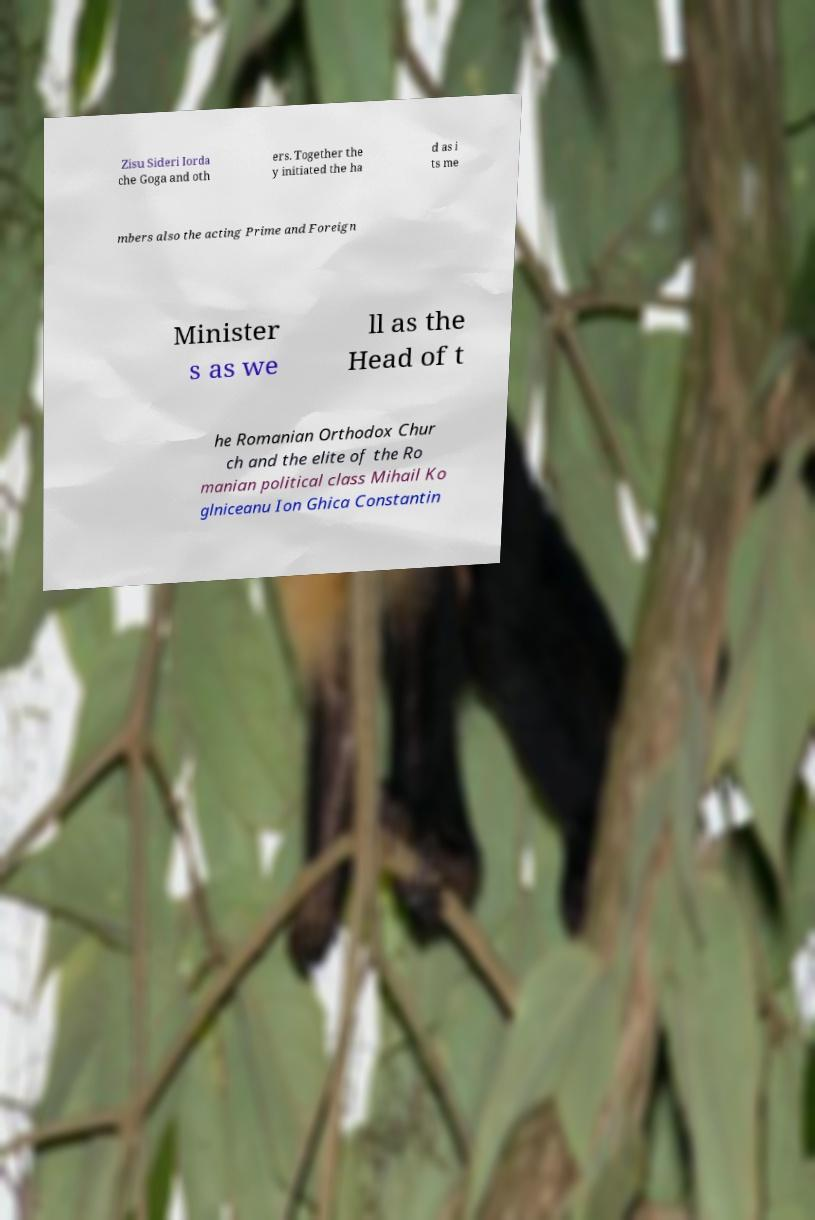Can you accurately transcribe the text from the provided image for me? Zisu Sideri Iorda che Goga and oth ers. Together the y initiated the ha d as i ts me mbers also the acting Prime and Foreign Minister s as we ll as the Head of t he Romanian Orthodox Chur ch and the elite of the Ro manian political class Mihail Ko glniceanu Ion Ghica Constantin 